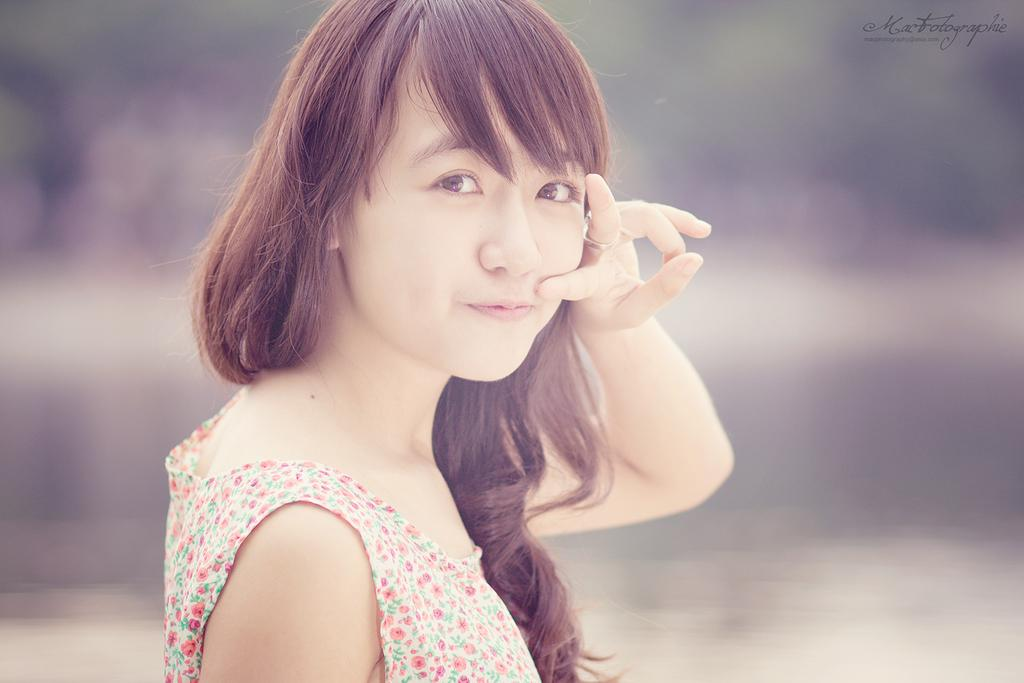What is present in the image? There is a woman in the image. Can you describe what the woman is wearing? The woman is wearing a floral top. What type of scissors is the woman using in the image? There are no scissors present in the image. What kind of badge is the woman wearing in the image? There is no badge present in the image. 